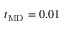Convert formula to latex. <formula><loc_0><loc_0><loc_500><loc_500>t _ { M D } = 0 . 0 1</formula> 